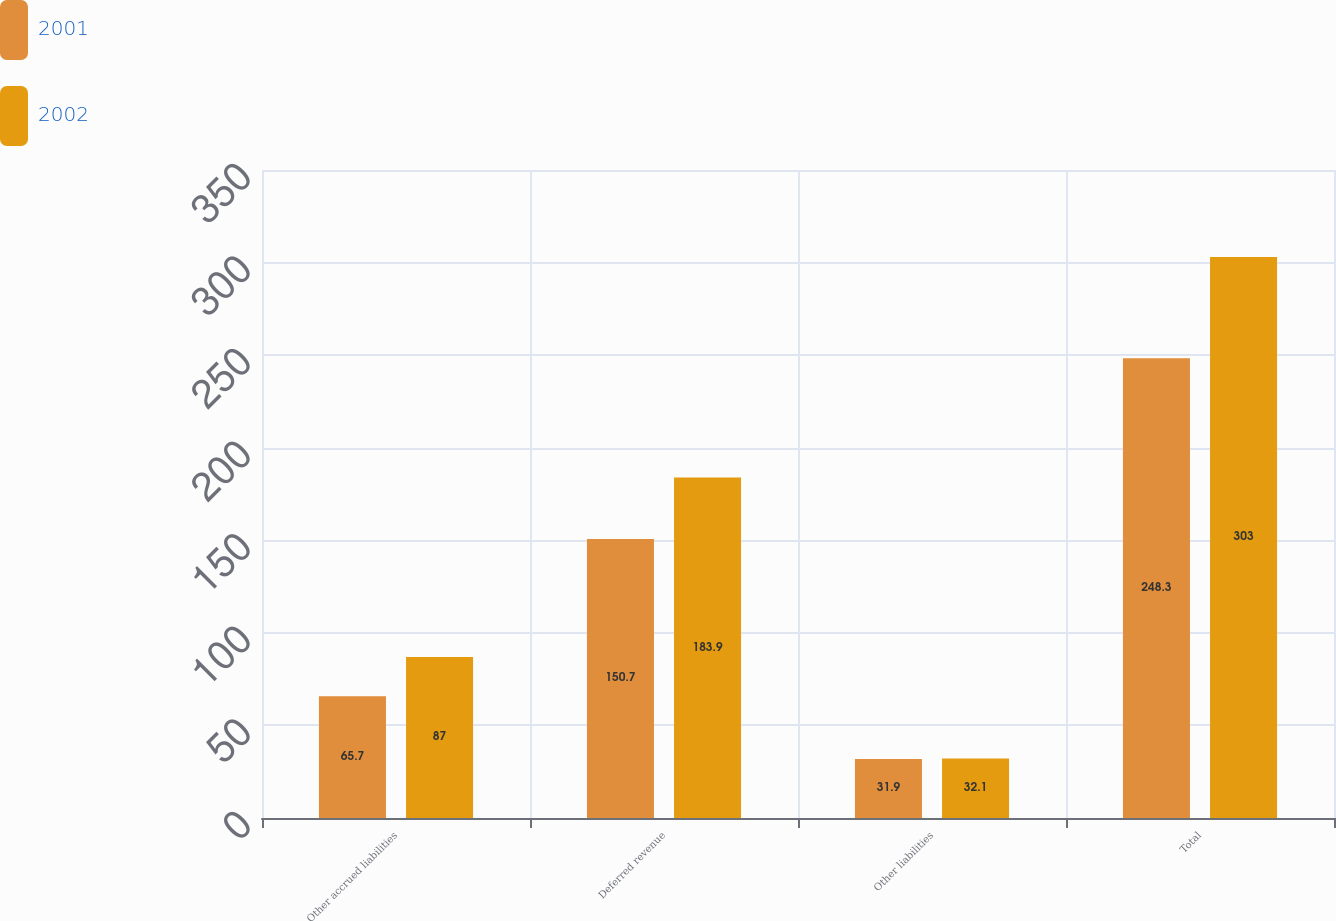<chart> <loc_0><loc_0><loc_500><loc_500><stacked_bar_chart><ecel><fcel>Other accrued liabilities<fcel>Deferred revenue<fcel>Other liabilities<fcel>Total<nl><fcel>2001<fcel>65.7<fcel>150.7<fcel>31.9<fcel>248.3<nl><fcel>2002<fcel>87<fcel>183.9<fcel>32.1<fcel>303<nl></chart> 